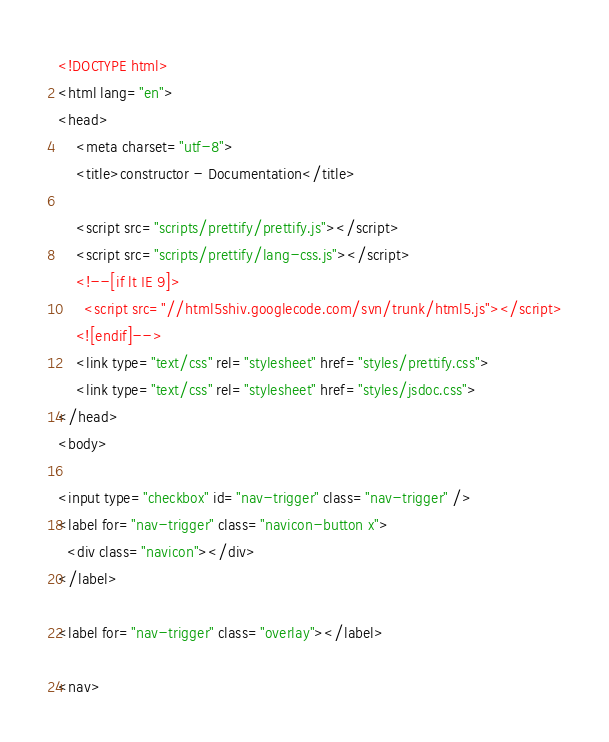<code> <loc_0><loc_0><loc_500><loc_500><_HTML_><!DOCTYPE html>
<html lang="en">
<head>
    <meta charset="utf-8">
    <title>constructor - Documentation</title>

    <script src="scripts/prettify/prettify.js"></script>
    <script src="scripts/prettify/lang-css.js"></script>
    <!--[if lt IE 9]>
      <script src="//html5shiv.googlecode.com/svn/trunk/html5.js"></script>
    <![endif]-->
    <link type="text/css" rel="stylesheet" href="styles/prettify.css">
    <link type="text/css" rel="stylesheet" href="styles/jsdoc.css">
</head>
<body>

<input type="checkbox" id="nav-trigger" class="nav-trigger" />
<label for="nav-trigger" class="navicon-button x">
  <div class="navicon"></div>
</label>

<label for="nav-trigger" class="overlay"></label>

<nav></code> 